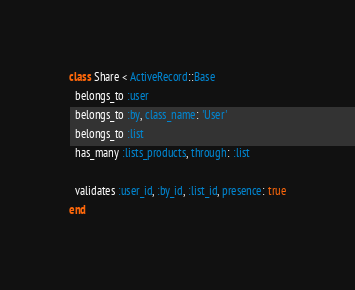Convert code to text. <code><loc_0><loc_0><loc_500><loc_500><_Ruby_>class Share < ActiveRecord::Base
  belongs_to :user
  belongs_to :by, class_name: 'User'
  belongs_to :list
  has_many :lists_products, through: :list

  validates :user_id, :by_id, :list_id, presence: true
end
</code> 